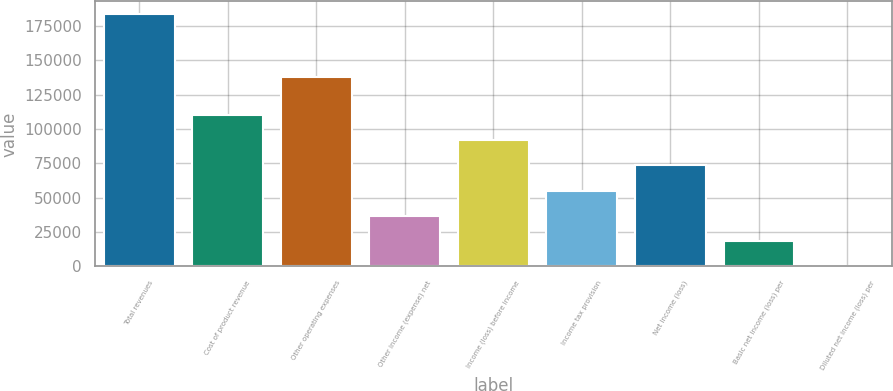Convert chart. <chart><loc_0><loc_0><loc_500><loc_500><bar_chart><fcel>Total revenues<fcel>Cost of product revenue<fcel>Other operating expenses<fcel>Other income (expense) net<fcel>Income (loss) before income<fcel>Income tax provision<fcel>Net income (loss)<fcel>Basic net income (loss) per<fcel>Diluted net income (loss) per<nl><fcel>183643<fcel>110186<fcel>137958<fcel>36728.7<fcel>91821.6<fcel>55093<fcel>73457.3<fcel>18364.5<fcel>0.18<nl></chart> 